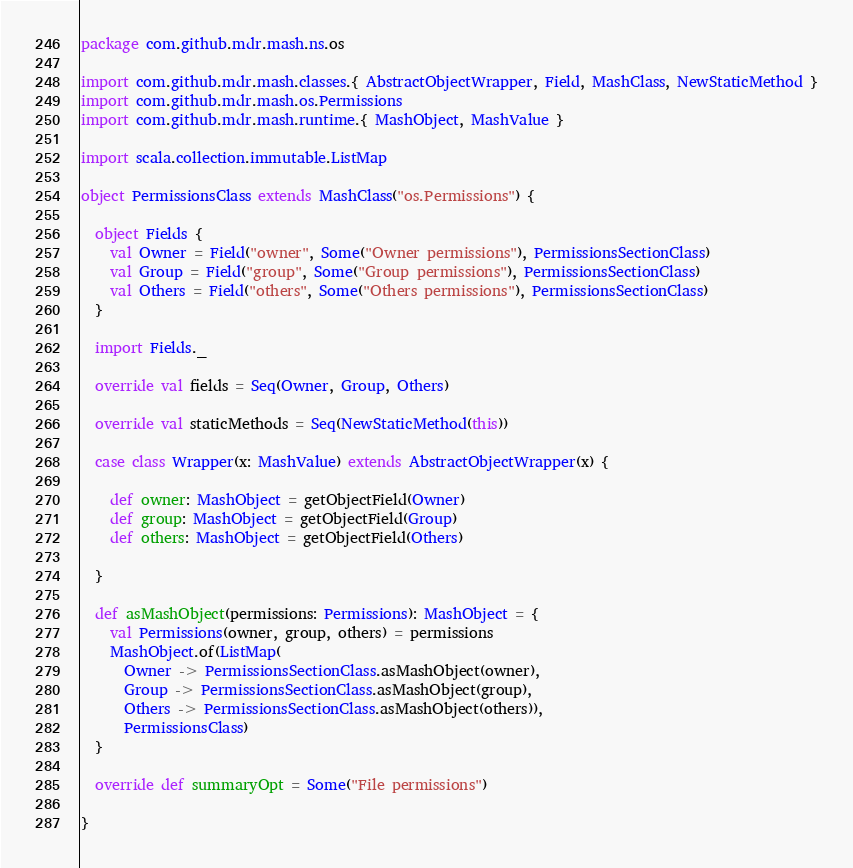<code> <loc_0><loc_0><loc_500><loc_500><_Scala_>package com.github.mdr.mash.ns.os

import com.github.mdr.mash.classes.{ AbstractObjectWrapper, Field, MashClass, NewStaticMethod }
import com.github.mdr.mash.os.Permissions
import com.github.mdr.mash.runtime.{ MashObject, MashValue }

import scala.collection.immutable.ListMap

object PermissionsClass extends MashClass("os.Permissions") {

  object Fields {
    val Owner = Field("owner", Some("Owner permissions"), PermissionsSectionClass)
    val Group = Field("group", Some("Group permissions"), PermissionsSectionClass)
    val Others = Field("others", Some("Others permissions"), PermissionsSectionClass)
  }

  import Fields._

  override val fields = Seq(Owner, Group, Others)

  override val staticMethods = Seq(NewStaticMethod(this))

  case class Wrapper(x: MashValue) extends AbstractObjectWrapper(x) {

    def owner: MashObject = getObjectField(Owner)
    def group: MashObject = getObjectField(Group)
    def others: MashObject = getObjectField(Others)

  }

  def asMashObject(permissions: Permissions): MashObject = {
    val Permissions(owner, group, others) = permissions
    MashObject.of(ListMap(
      Owner -> PermissionsSectionClass.asMashObject(owner),
      Group -> PermissionsSectionClass.asMashObject(group),
      Others -> PermissionsSectionClass.asMashObject(others)),
      PermissionsClass)
  }

  override def summaryOpt = Some("File permissions")

}</code> 